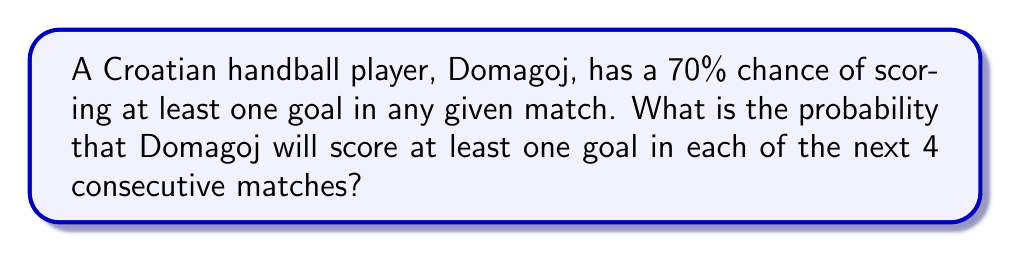What is the answer to this math problem? Let's approach this step-by-step:

1) First, we need to understand that for Domagoj to score in all 4 consecutive matches, he needs to succeed in each individual match independently.

2) The probability of Domagoj scoring in a single match is 70% or 0.7.

3) To find the probability of this happening in all 4 matches, we need to multiply the individual probabilities:

   $$P(\text{scoring in all 4 matches}) = 0.7 \times 0.7 \times 0.7 \times 0.7$$

4) This is equivalent to:

   $$P(\text{scoring in all 4 matches}) = 0.7^4$$

5) Let's calculate this:

   $$0.7^4 = 0.2401$$

6) Converting to a percentage:

   $$0.2401 \times 100\% = 24.01\%$$

Thus, there is a 24.01% chance that Domagoj will score at least one goal in each of the next 4 consecutive matches.
Answer: $0.2401$ or $24.01\%$ 